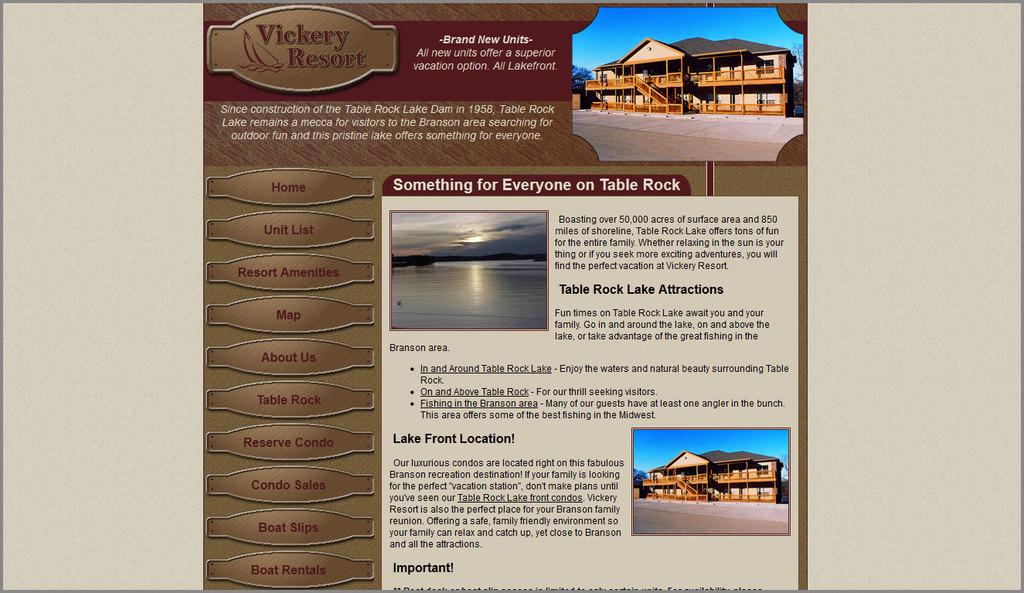<image>
Render a clear and concise summary of the photo. A website for the Vickery Resort advertises brand new units. 